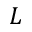<formula> <loc_0><loc_0><loc_500><loc_500>L</formula> 